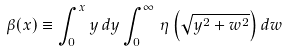<formula> <loc_0><loc_0><loc_500><loc_500>\beta ( x ) \equiv \int _ { 0 } ^ { x } y \, d y \int _ { 0 } ^ { \infty } \, \eta \left ( \sqrt { y ^ { 2 } + w ^ { 2 } } \right ) d w</formula> 